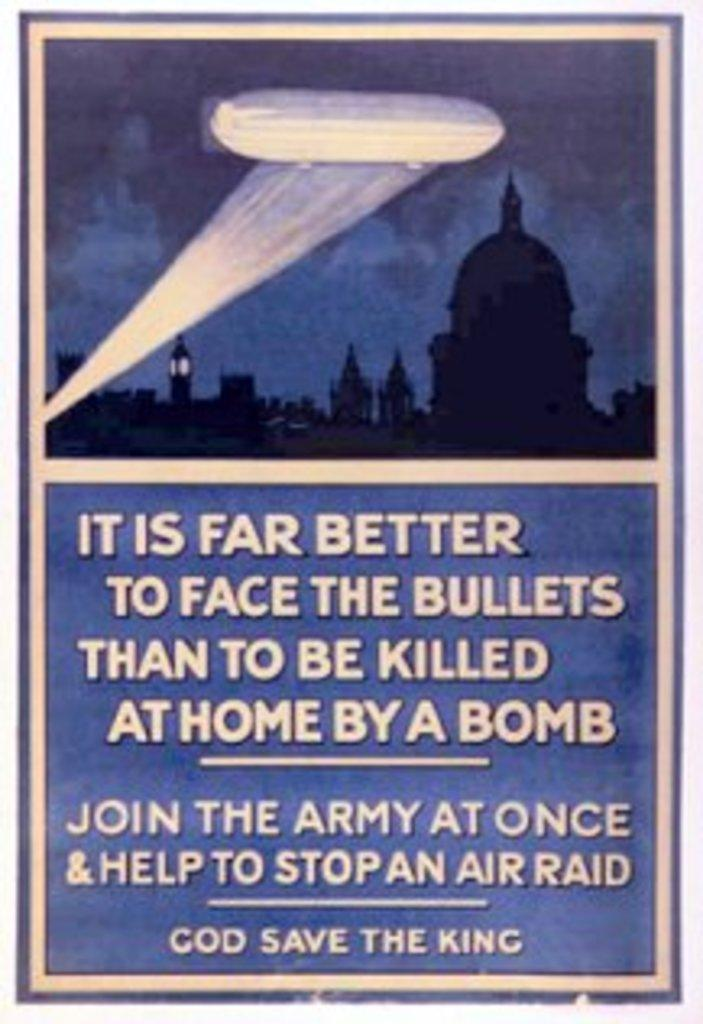<image>
Provide a brief description of the given image. A blue poster says, "God Save the King." 